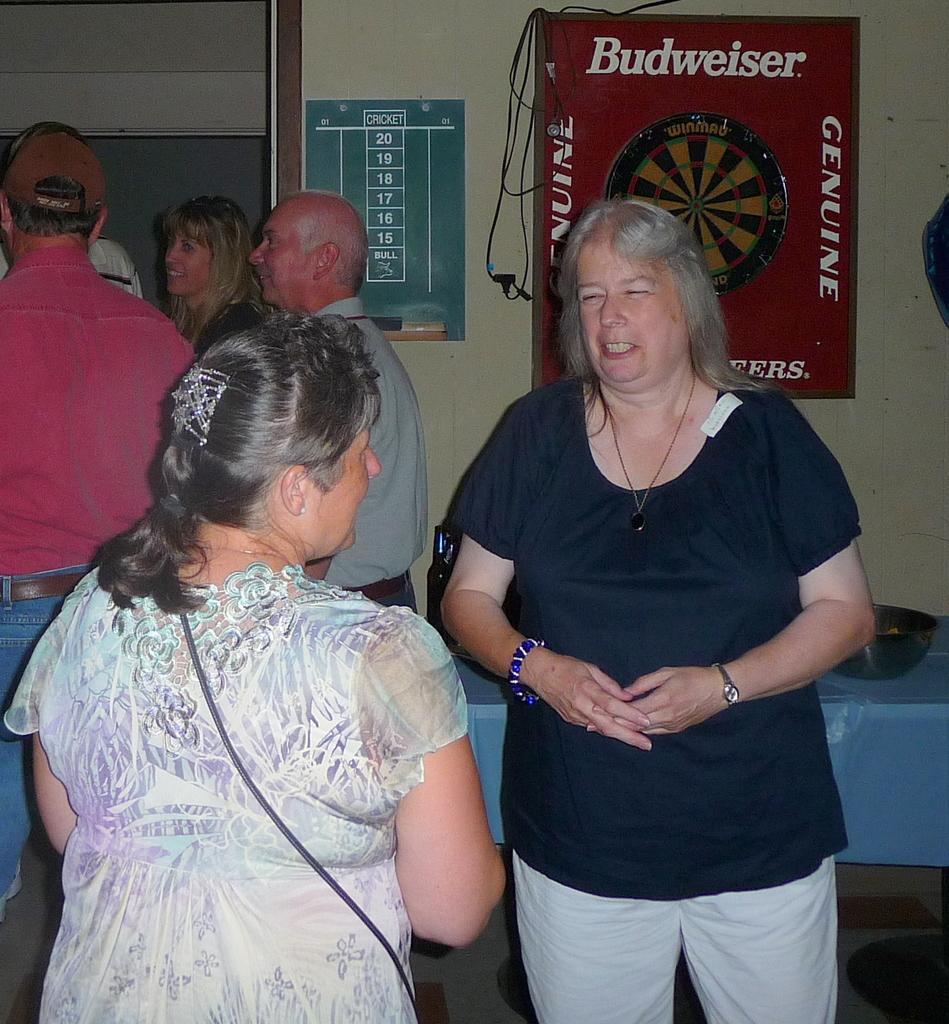Can you describe this image briefly? In the center of this picture we can see the group of persons standing. In the background we can see the wall and we can see the boards on which we can see the text and there is a table on the top of which some items are placed and we can see the circular target in the background. 